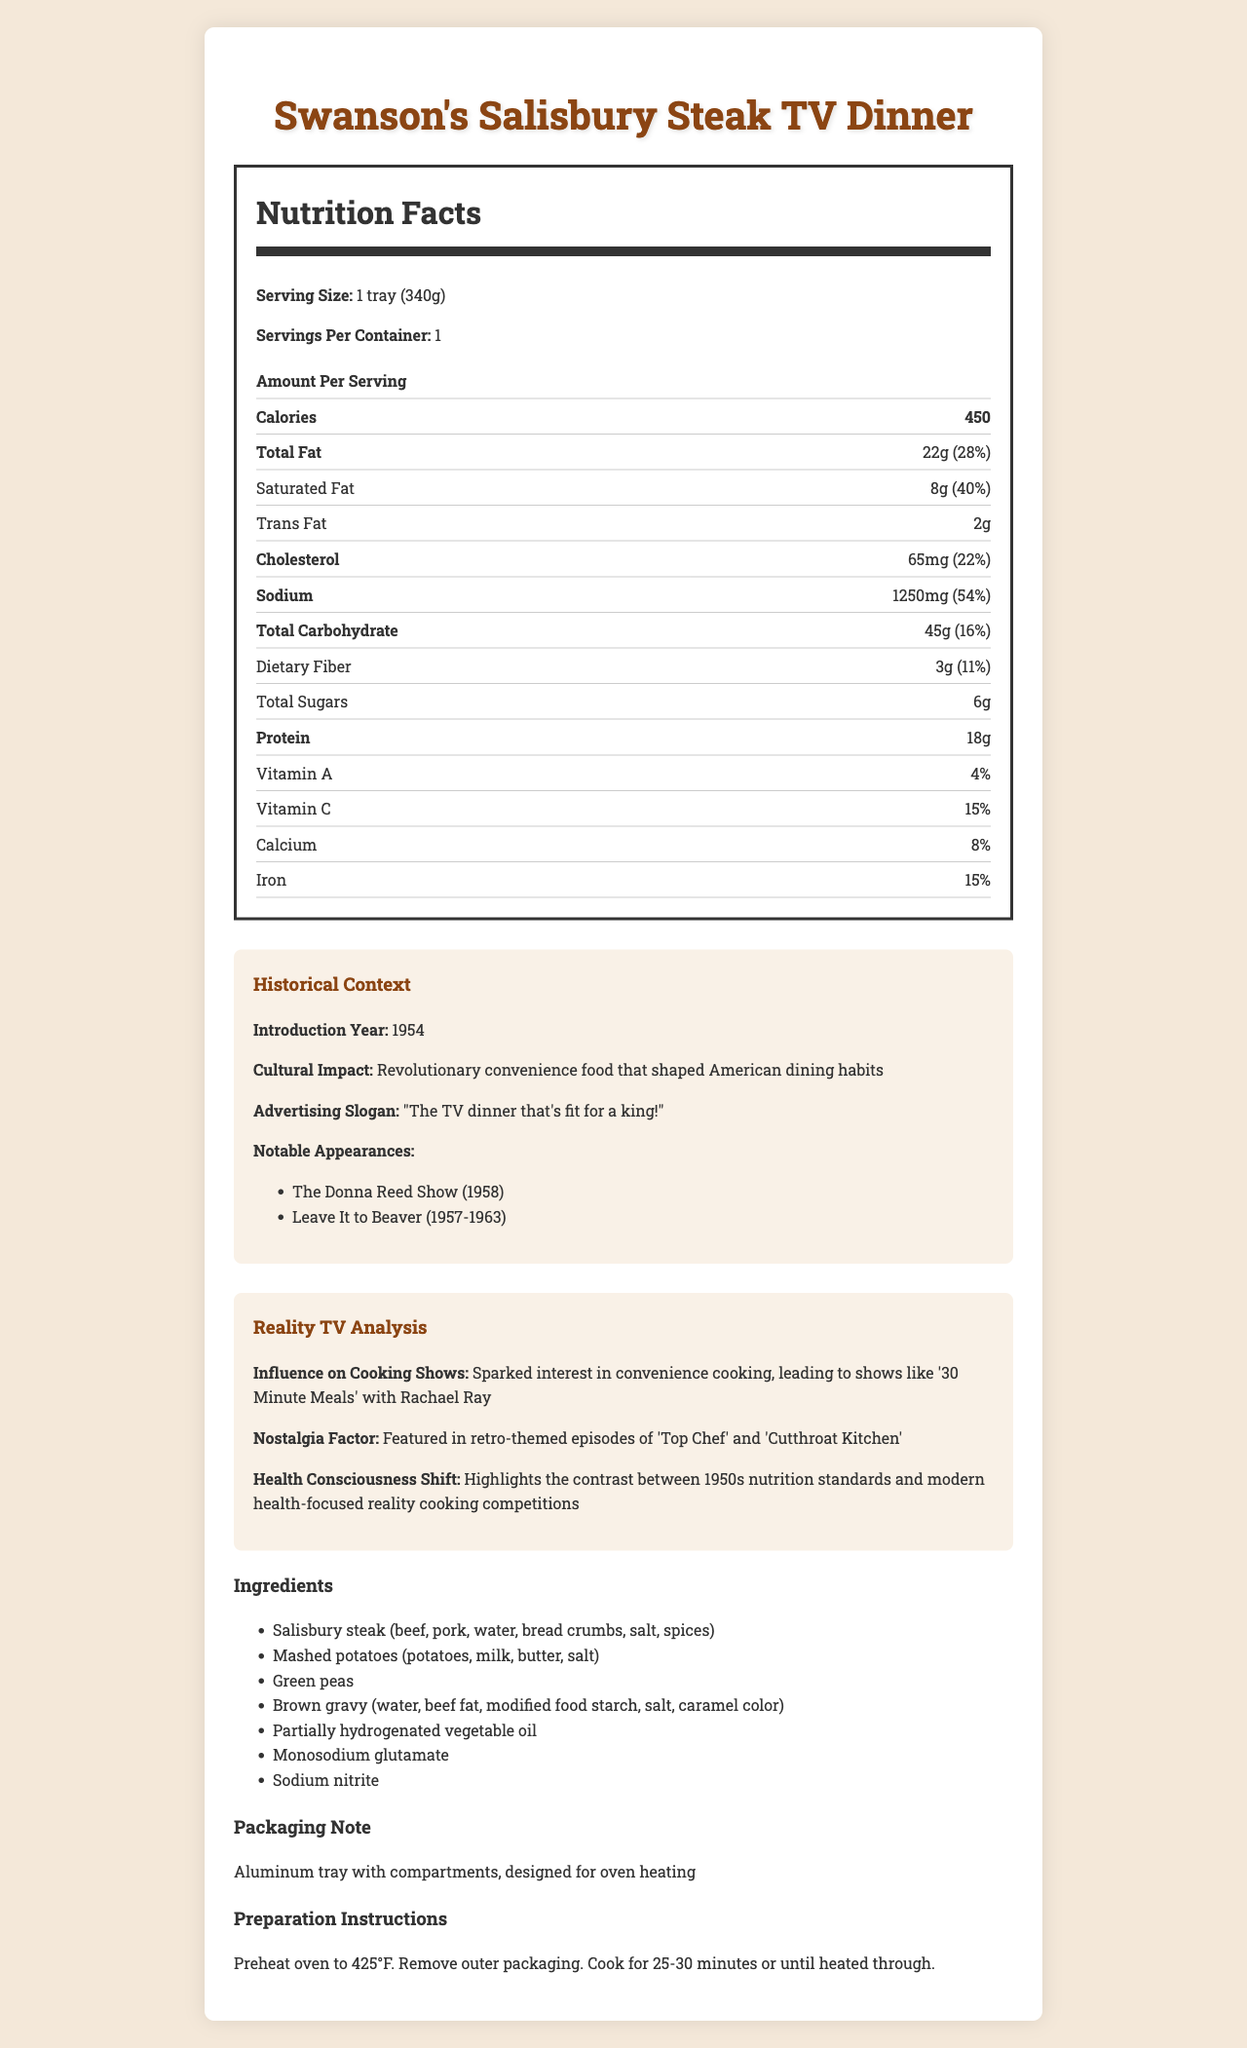what is the serving size of Swanson's Salisbury Steak TV Dinner? The serving size mentioned in the 'Nutrition Facts' section is '1 tray (340g)'.
Answer: 1 tray (340g) how much trans fat is in a serving of this TV dinner? The 'Nutrition Facts' section lists the trans fat content as 2 grams per serving.
Answer: 2 grams what is the total amount of sodium in one serving of this TV dinner? The 'Nutrition Facts' section specifies that there are 1250 milligrams of sodium per serving.
Answer: 1250 milligrams what percentage of the daily value of sodium does this TV dinner provide? According to the 'Nutrition Facts' section, the TV dinner provides 54% of the daily value of sodium per serving.
Answer: 54% which ingredient is not present in this TV dinner? A. Partially hydrogenated vegetable oil B. Monosodium glutamate C. Salt D. Gluten The ingredient list includes partially hydrogenated vegetable oil, monosodium glutamate, and salt, but 'gluten' is not explicitly mentioned.
Answer: D what is the main factor that sparked the interest in convenience cooking shows according to the document? The 'reality-tv-analysis' section mentions that Swanson's TV Dinners sparked interest in convenience cooking, leading to shows like '30 Minute Meals' with Rachael Ray.
Answer: The introduction of Swanson's TV Dinners which TV shows featured Swanson's Salisbury Steak TV Dinner? A. The Donna Reed Show B. Leave It to Beaver C. Both of the above D. None of the above The 'historical-context' section lists both 'The Donna Reed Show' and 'Leave It to Beaver' as notable appearances.
Answer: C is the content of this TV dinner healthy according to modern standards? The high amount of trans fats and sodium content (54% daily value) make it unhealthy by modern standards focused on reducing these components in diets.
Answer: No what does the term 'revolutionary convenience food' refer to in the document? The 'historical-context' section describes Swanson's TV Dinner as a 'revolutionary convenience food that shaped American dining habits'.
Answer: Swanson's TV Dinner summarize the main idea of the document. The document presents the nutrition information, including significant components like trans fats and sodium, and offers historical context such as the introduction year, cultural impact, and notable appearances. It also analyzes how the TV dinner influenced convenience cooking shows and health consciousness in reality TV.
Answer: The document provides detailed nutrition facts, historical context, and analysis of Swanson's Salisbury Steak TV Dinner, focusing on its impact on American dining habits and reality TV trends. how did Swanson's TV Dinner contrast with modern health-focused reality cooking competitions? The 'reality-tv-analysis' section notes that the high content of trans fats and sodium in Swanson's TV Dinner contrasts with modern health-focused cooking competitions.
Answer: By highlighting the difference between 1950s nutrition standards and contemporary health-conscious practices. what is the preparation method for this TV dinner? The 'preparation-instructions' section outlines these steps for heating the TV dinner.
Answer: Preheat oven to 425°F. Remove outer packaging. Cook for 25-30 minutes or until heated through. how much protein does one serving of Swanson's Salisbury Steak TV Dinner contain? A. 15 grams B. 18 grams C. 20 grams D. 25 grams The 'Nutrition Facts' section indicates that one serving contains 18 grams of protein.
Answer: B what year was Swanson's Salisbury Steak TV Dinner introduced? The 'historical-context' section states that this TV dinner was introduced in 1954.
Answer: 1954 how many daily values are provided in the document for the vitamins included? The document mentions daily values for Vitamin A (4%), Vitamin C (15%), Calcium (8%), and Iron (15%).
Answer: 4 can you determine the amount of gluten in Swanson's Salisbury Steak TV Dinner? The document does not provide any specific information regarding gluten content.
Answer: Cannot be determined 